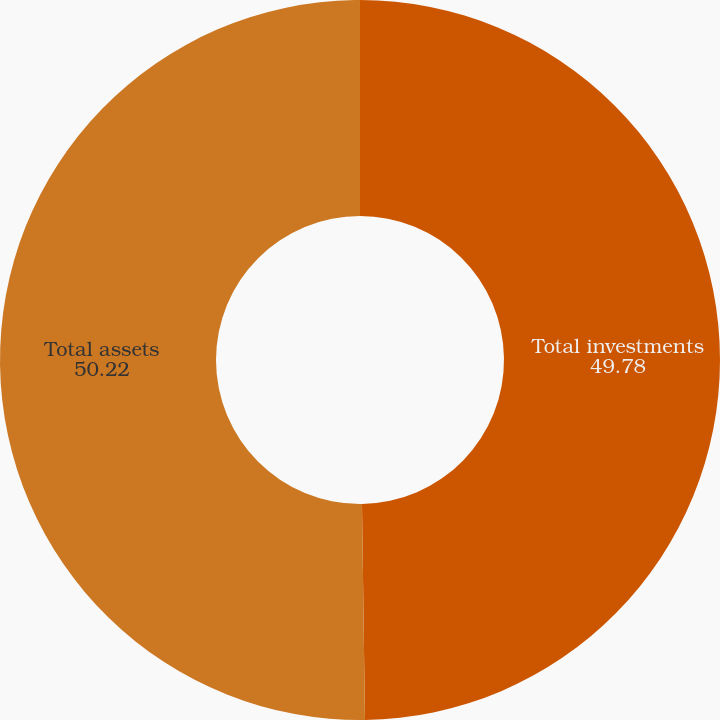Convert chart. <chart><loc_0><loc_0><loc_500><loc_500><pie_chart><fcel>Total investments<fcel>Total assets<nl><fcel>49.78%<fcel>50.22%<nl></chart> 